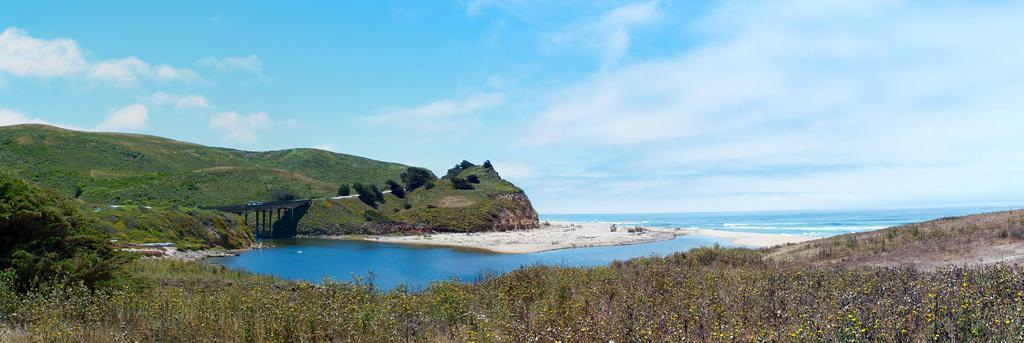What type of vegetation can be seen in the image? There are plants and trees in the image. What geographical feature is present in the image? There is a hill in the image. What man-made structure can be seen in the image? There is a bridge in the image. What architectural elements are visible in the image? There are pillars in the image. What pathway is present in the image? There is a walkway in the image. What natural element is present in the image? There is water in the image. What can be seen in the background of the image? The sky is visible in the background of the image. How many cattle are grazing on the hill in the image? There are no cattle present in the image. What type of vessel is floating on the water in the image? There is no vessel present in the image; it only shows water. What is the air quality like in the image? The air quality cannot be determined from the image, as there is no information provided about it. 